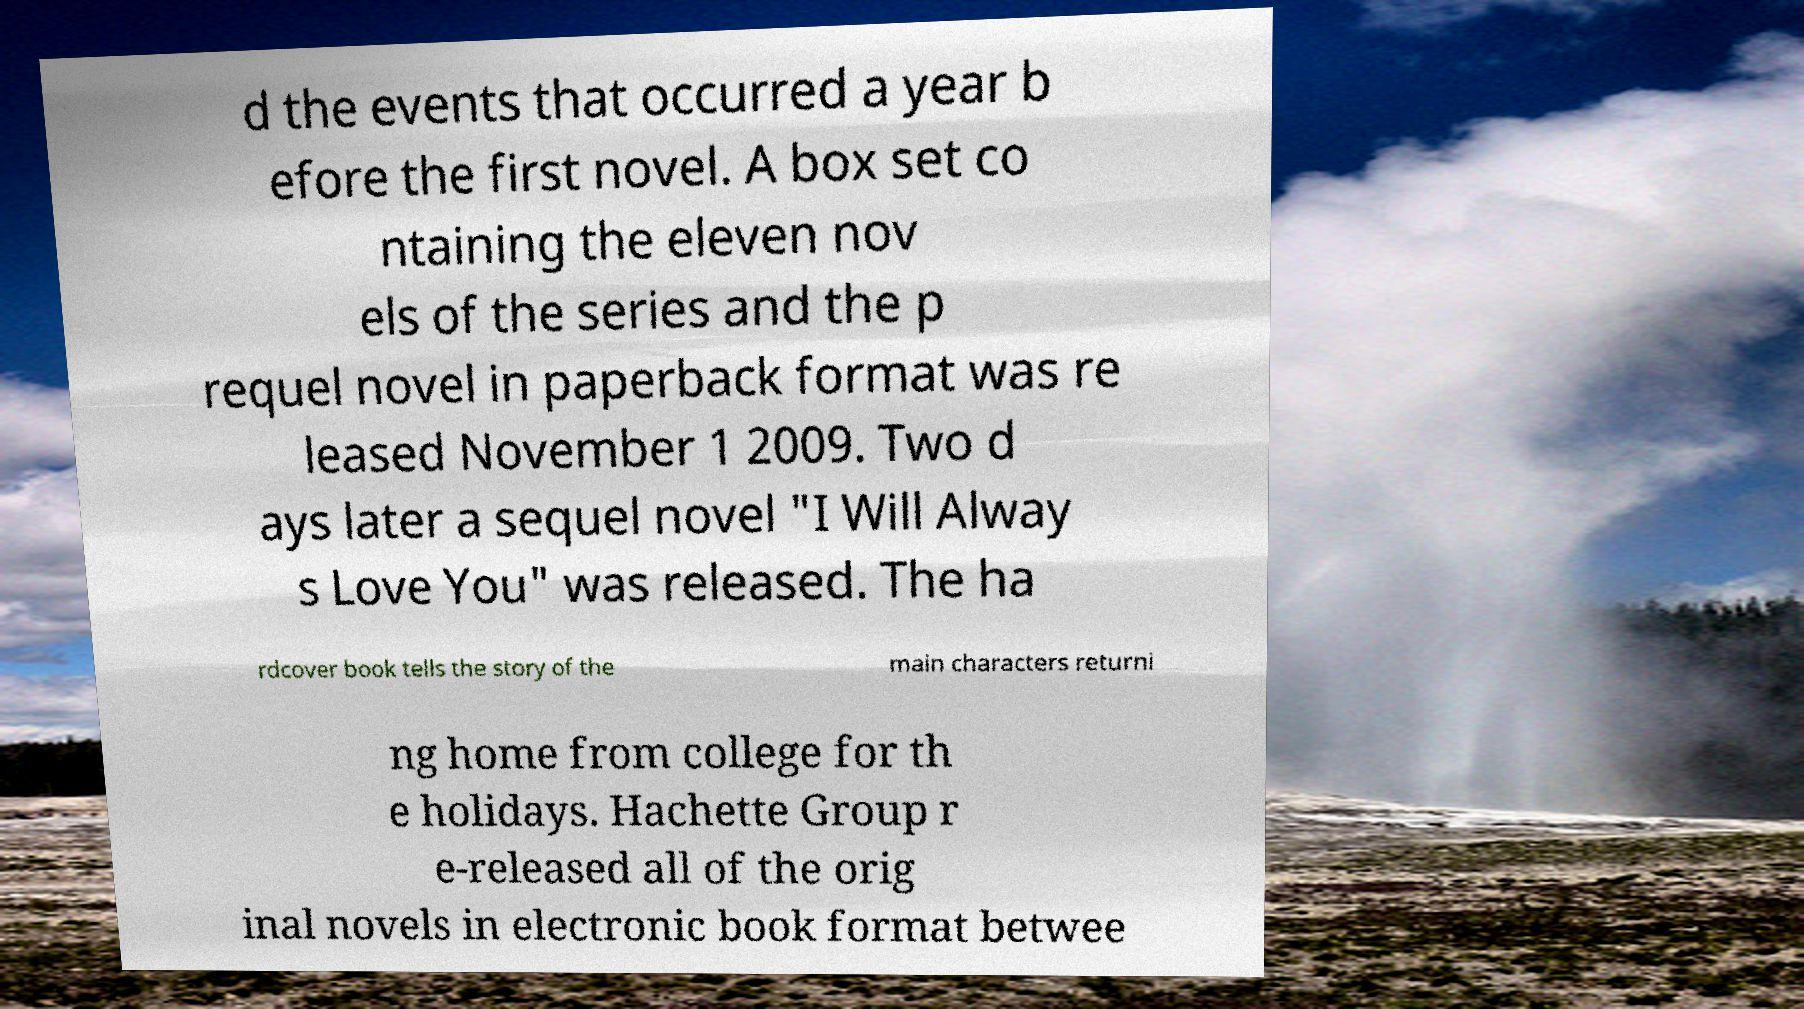Can you read and provide the text displayed in the image?This photo seems to have some interesting text. Can you extract and type it out for me? d the events that occurred a year b efore the first novel. A box set co ntaining the eleven nov els of the series and the p requel novel in paperback format was re leased November 1 2009. Two d ays later a sequel novel "I Will Alway s Love You" was released. The ha rdcover book tells the story of the main characters returni ng home from college for th e holidays. Hachette Group r e-released all of the orig inal novels in electronic book format betwee 